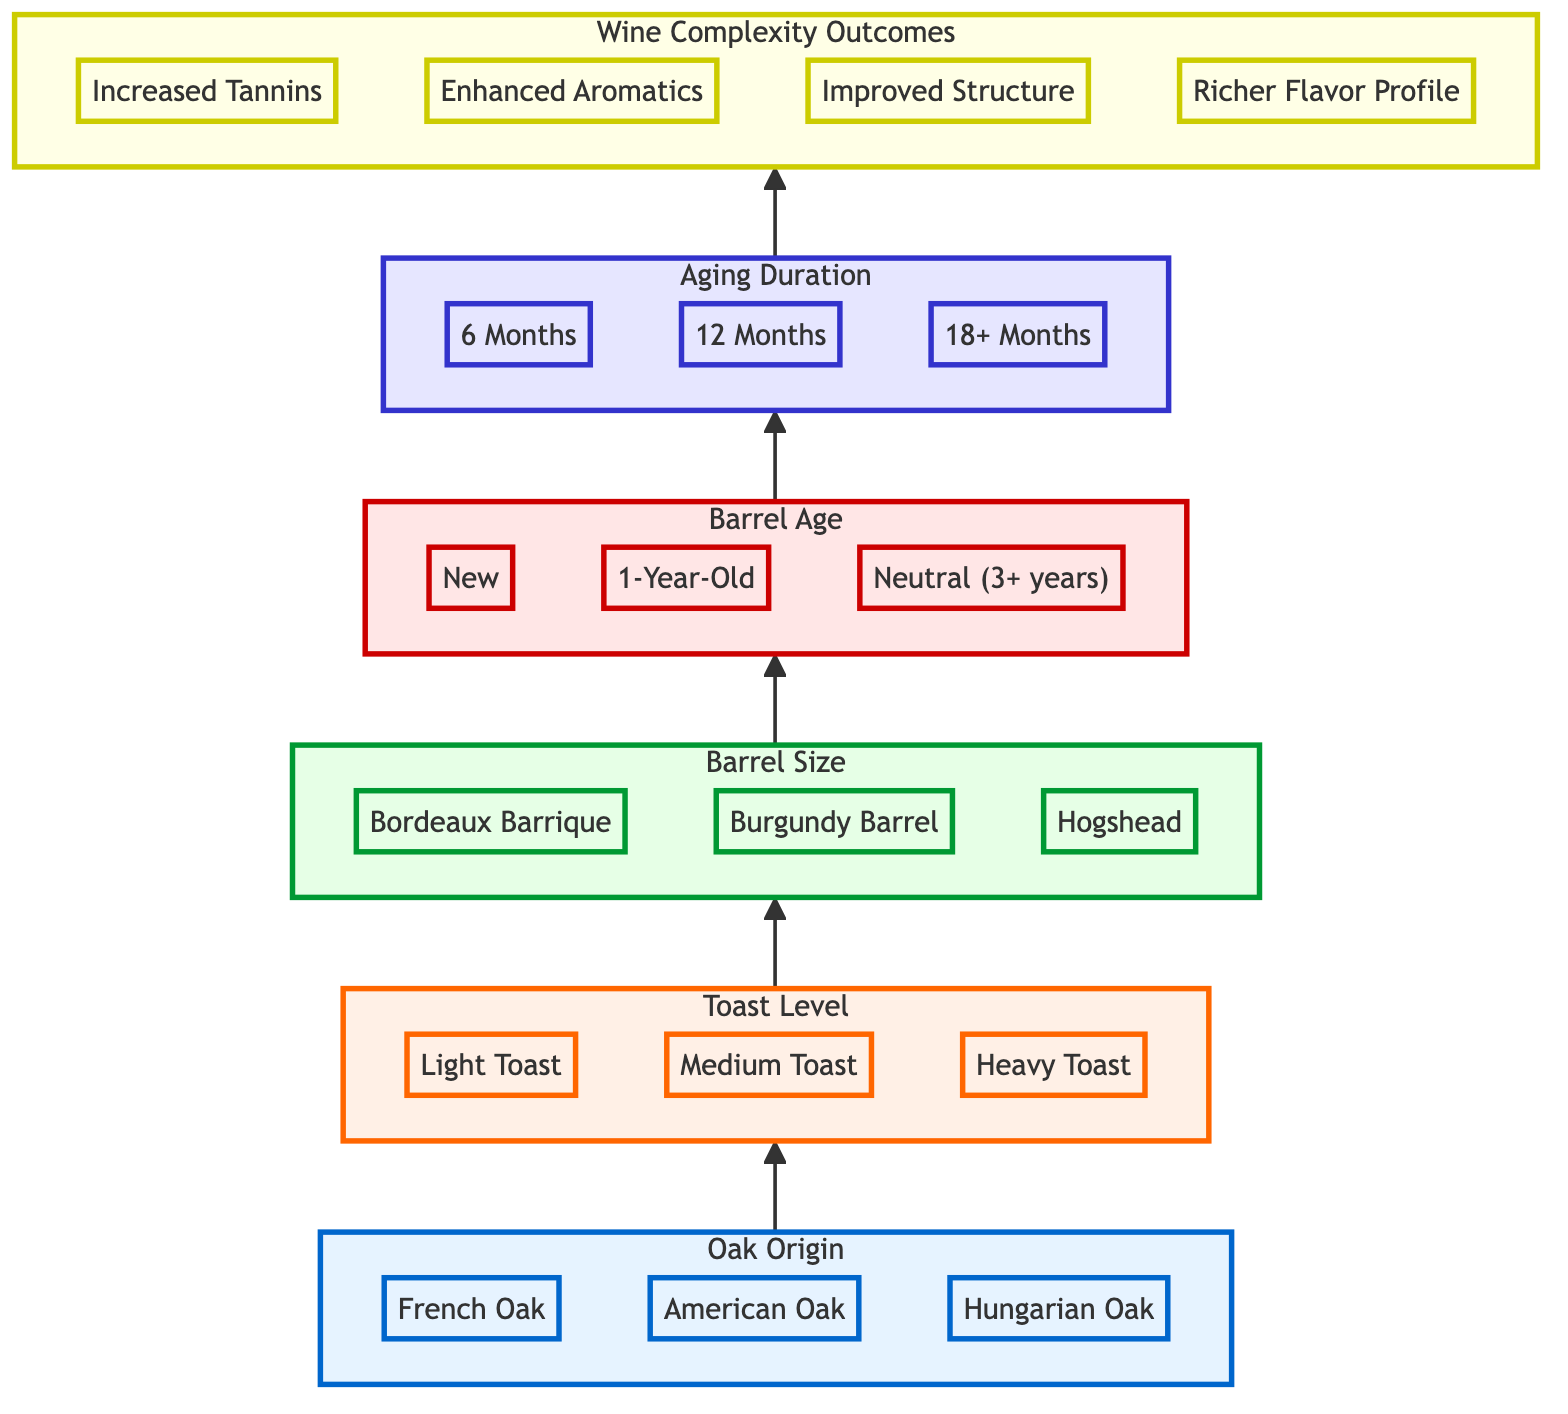What is the top level of the diagram? The top level of the diagram is "Wine Complexity Outcomes," which represents the final results stemming from the preceding variables.
Answer: Wine Complexity Outcomes How many barrel types are listed under "Oak Origin"? There are three types of barrels listed under "Oak Origin": French Oak, American Oak, and Hungarian Oak.
Answer: 3 Which toast level comes before "Barrel Size"? The toast level that comes before "Barrel Size" is "Toast Level." This is directly connected in the flow of the diagram.
Answer: Toast Level What is the maximum aging duration listed? The maximum aging duration listed in the diagram is "18+ Months," which is part of the final aging duration node that leads to wine complexity outcomes.
Answer: 18+ Months Which barrel age is categorized as "Neutral"? The barrel age that is categorized as "Neutral" is "Neutral (3+ years),” indicating a barrel that has been previously used for three years or more.
Answer: Neutral (3+ years) If a wine uses "French Oak" and "Heavy Toast," what is a possible outcome? Given the flow from "Oak Origin" to "Wine Complexity Outcomes," a possible outcome from using "French Oak" and "Heavy Toast" would be "Increased Tannins," as heavier toasts often contribute to tannin extraction.
Answer: Increased Tannins What is the sequence leading to "Richer Flavor Profile"? The sequence leading to "Richer Flavor Profile" begins with "Oak Origin," progresses through "Toast Level," "Barrel Size," "Barrel Age," and "Aging Duration," eventually reaching the final outcome node.
Answer: Oak Origin → Toast Level → Barrel Size → Barrel Age → Aging Duration What is the relationship between "Barrel Age" and "Aging Duration"? "Barrel Age" directly influences the "Aging Duration," as the aging process of the wine is dependent on the prior age of the barrel used for aging.
Answer: Directly influences What is the color coding for "Aging Duration"? The color coding for "Aging Duration" is a light blue shade, indicated by the class definition for level five in the diagram, which helps differentiate it from other levels.
Answer: Light blue 